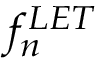<formula> <loc_0><loc_0><loc_500><loc_500>f _ { n } ^ { L E T }</formula> 